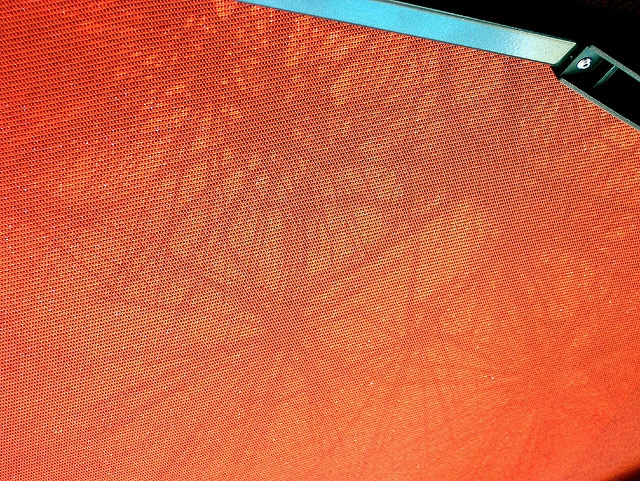Describe the objects in this image and their specific colors. I can see a umbrella in red, salmon, and brown tones in this image. 